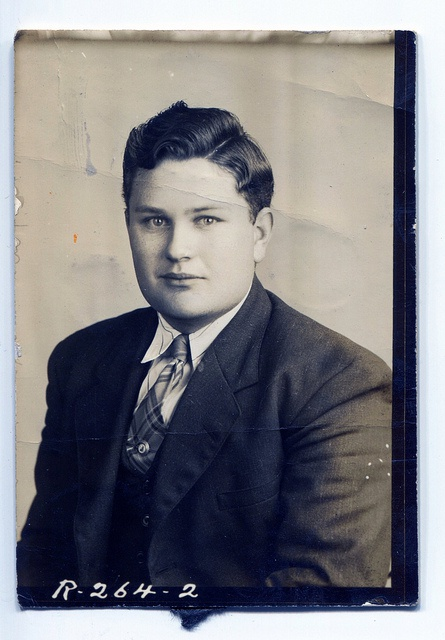Describe the objects in this image and their specific colors. I can see people in white, black, gray, and darkgray tones and tie in white, black, gray, and darkgray tones in this image. 